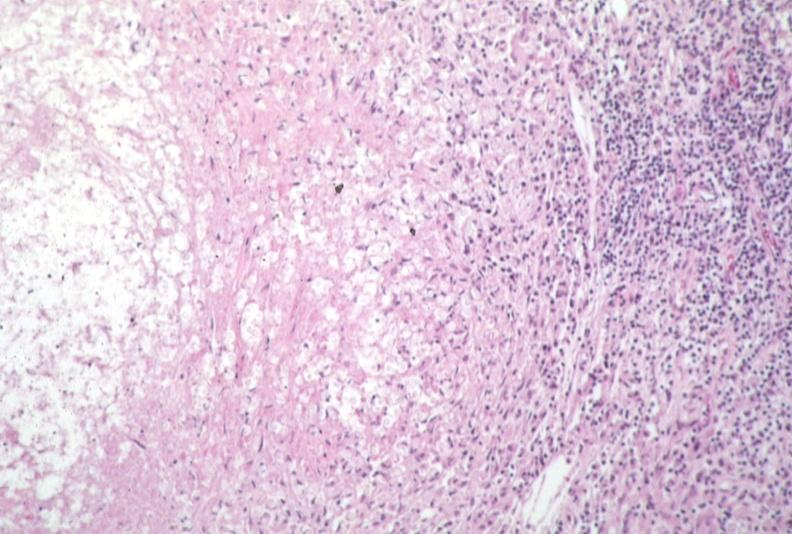what does this image show?
Answer the question using a single word or phrase. Lymph node 